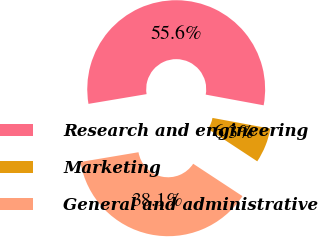<chart> <loc_0><loc_0><loc_500><loc_500><pie_chart><fcel>Research and engineering<fcel>Marketing<fcel>General and administrative<nl><fcel>55.56%<fcel>6.35%<fcel>38.1%<nl></chart> 